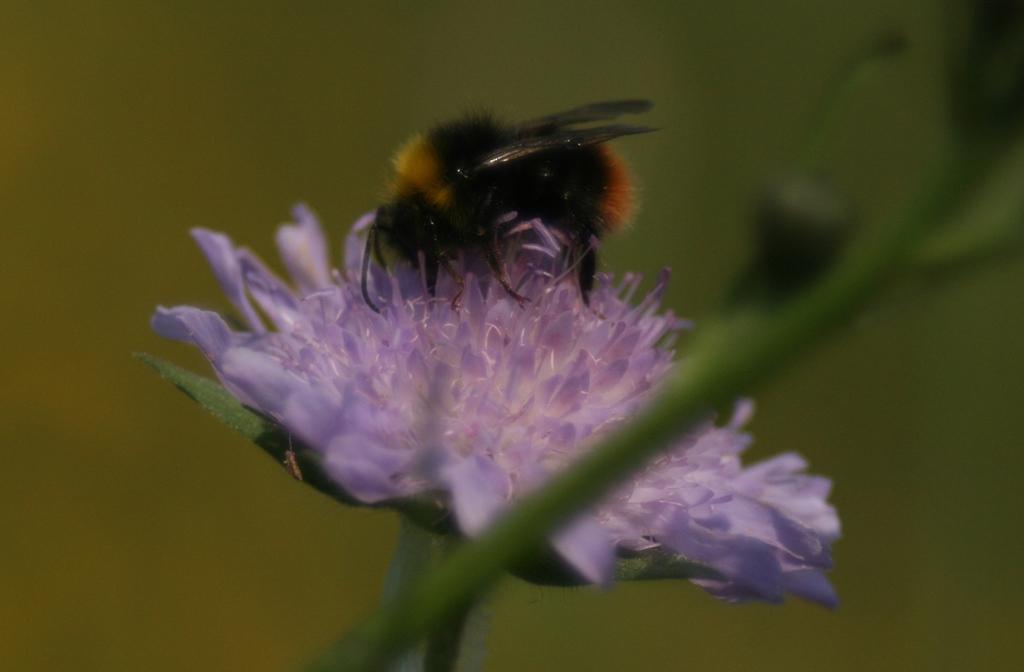Could you give a brief overview of what you see in this image? In this picture we can see an insect on a flower, stem and in the background it is blurry. 